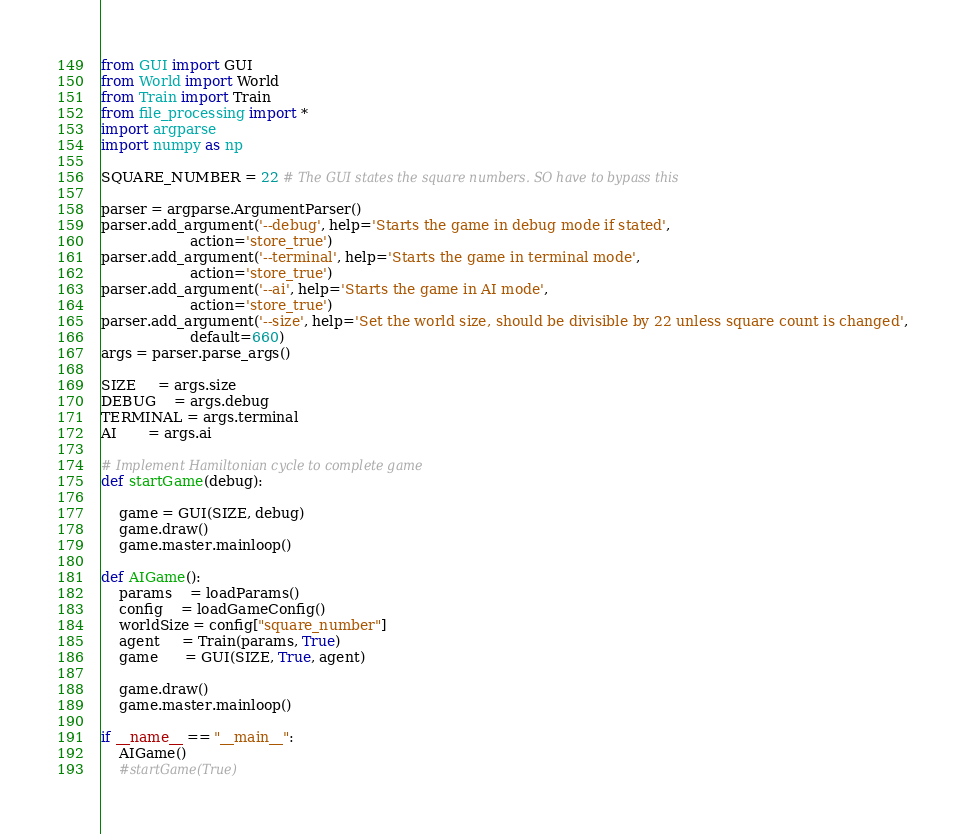Convert code to text. <code><loc_0><loc_0><loc_500><loc_500><_Python_>from GUI import GUI
from World import World
from Train import Train
from file_processing import *
import argparse
import numpy as np

SQUARE_NUMBER = 22 # The GUI states the square numbers. SO have to bypass this
    
parser = argparse.ArgumentParser()
parser.add_argument('--debug', help='Starts the game in debug mode if stated',
                    action='store_true')
parser.add_argument('--terminal', help='Starts the game in terminal mode',
                    action='store_true')
parser.add_argument('--ai', help='Starts the game in AI mode',
                    action='store_true')
parser.add_argument('--size', help='Set the world size, should be divisible by 22 unless square count is changed',
                    default=660)
args = parser.parse_args()

SIZE     = args.size
DEBUG    = args.debug
TERMINAL = args.terminal
AI       = args.ai

# Implement Hamiltonian cycle to complete game
def startGame(debug):
    
    game = GUI(SIZE, debug)
    game.draw()
    game.master.mainloop()

def AIGame():
    params    = loadParams()
    config    = loadGameConfig()
    worldSize = config["square_number"]
    agent     = Train(params, True)
    game      = GUI(SIZE, True, agent)

    game.draw()
    game.master.mainloop()

if __name__ == "__main__":
    AIGame()
    #startGame(True)</code> 